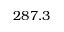Convert formula to latex. <formula><loc_0><loc_0><loc_500><loc_500>2 8 7 . 3</formula> 